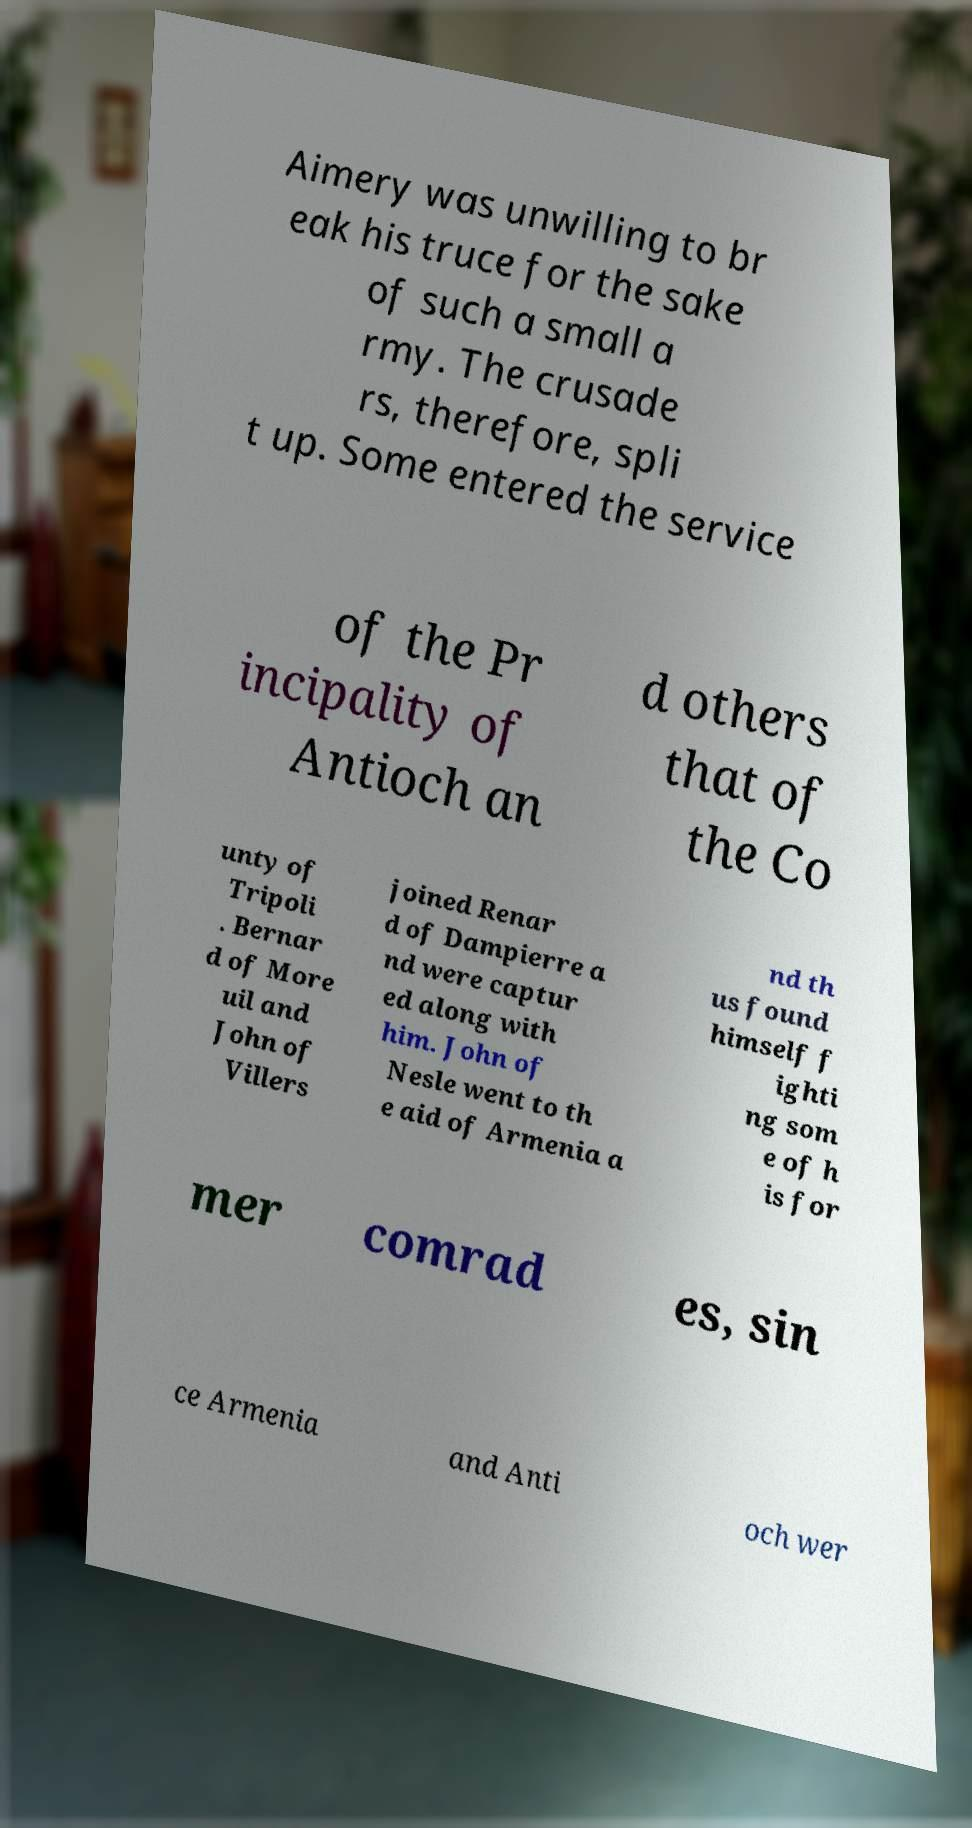Please identify and transcribe the text found in this image. Aimery was unwilling to br eak his truce for the sake of such a small a rmy. The crusade rs, therefore, spli t up. Some entered the service of the Pr incipality of Antioch an d others that of the Co unty of Tripoli . Bernar d of More uil and John of Villers joined Renar d of Dampierre a nd were captur ed along with him. John of Nesle went to th e aid of Armenia a nd th us found himself f ighti ng som e of h is for mer comrad es, sin ce Armenia and Anti och wer 